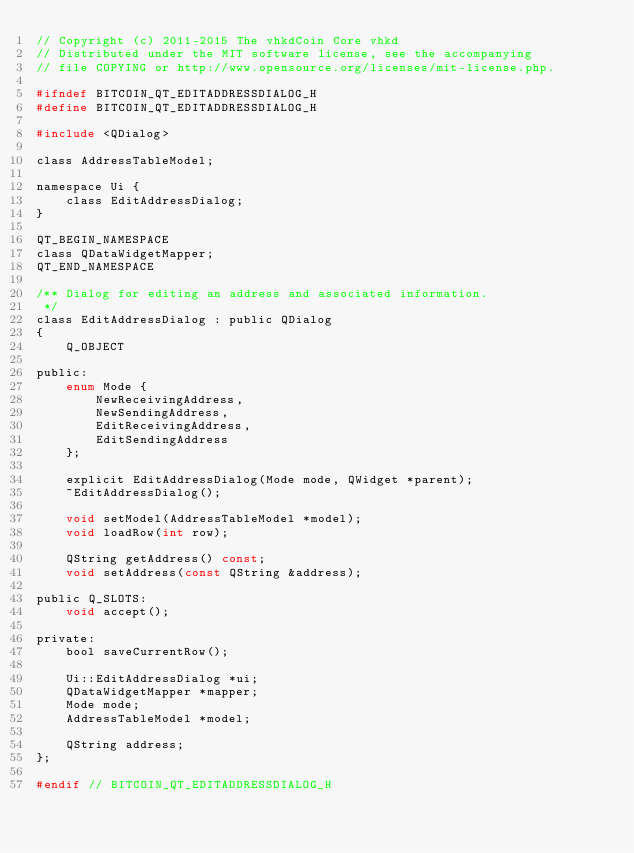<code> <loc_0><loc_0><loc_500><loc_500><_C_>// Copyright (c) 2011-2015 The vhkdCoin Core vhkd
// Distributed under the MIT software license, see the accompanying
// file COPYING or http://www.opensource.org/licenses/mit-license.php.

#ifndef BITCOIN_QT_EDITADDRESSDIALOG_H
#define BITCOIN_QT_EDITADDRESSDIALOG_H

#include <QDialog>

class AddressTableModel;

namespace Ui {
    class EditAddressDialog;
}

QT_BEGIN_NAMESPACE
class QDataWidgetMapper;
QT_END_NAMESPACE

/** Dialog for editing an address and associated information.
 */
class EditAddressDialog : public QDialog
{
    Q_OBJECT

public:
    enum Mode {
        NewReceivingAddress,
        NewSendingAddress,
        EditReceivingAddress,
        EditSendingAddress
    };

    explicit EditAddressDialog(Mode mode, QWidget *parent);
    ~EditAddressDialog();

    void setModel(AddressTableModel *model);
    void loadRow(int row);

    QString getAddress() const;
    void setAddress(const QString &address);

public Q_SLOTS:
    void accept();

private:
    bool saveCurrentRow();

    Ui::EditAddressDialog *ui;
    QDataWidgetMapper *mapper;
    Mode mode;
    AddressTableModel *model;

    QString address;
};

#endif // BITCOIN_QT_EDITADDRESSDIALOG_H
</code> 